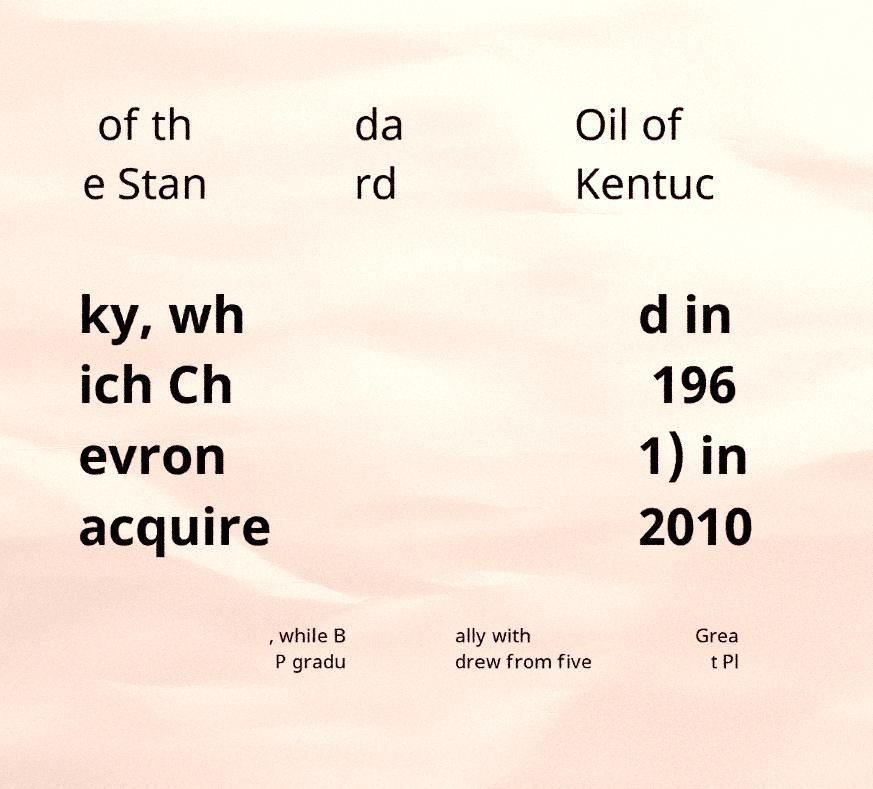For documentation purposes, I need the text within this image transcribed. Could you provide that? of th e Stan da rd Oil of Kentuc ky, wh ich Ch evron acquire d in 196 1) in 2010 , while B P gradu ally with drew from five Grea t Pl 